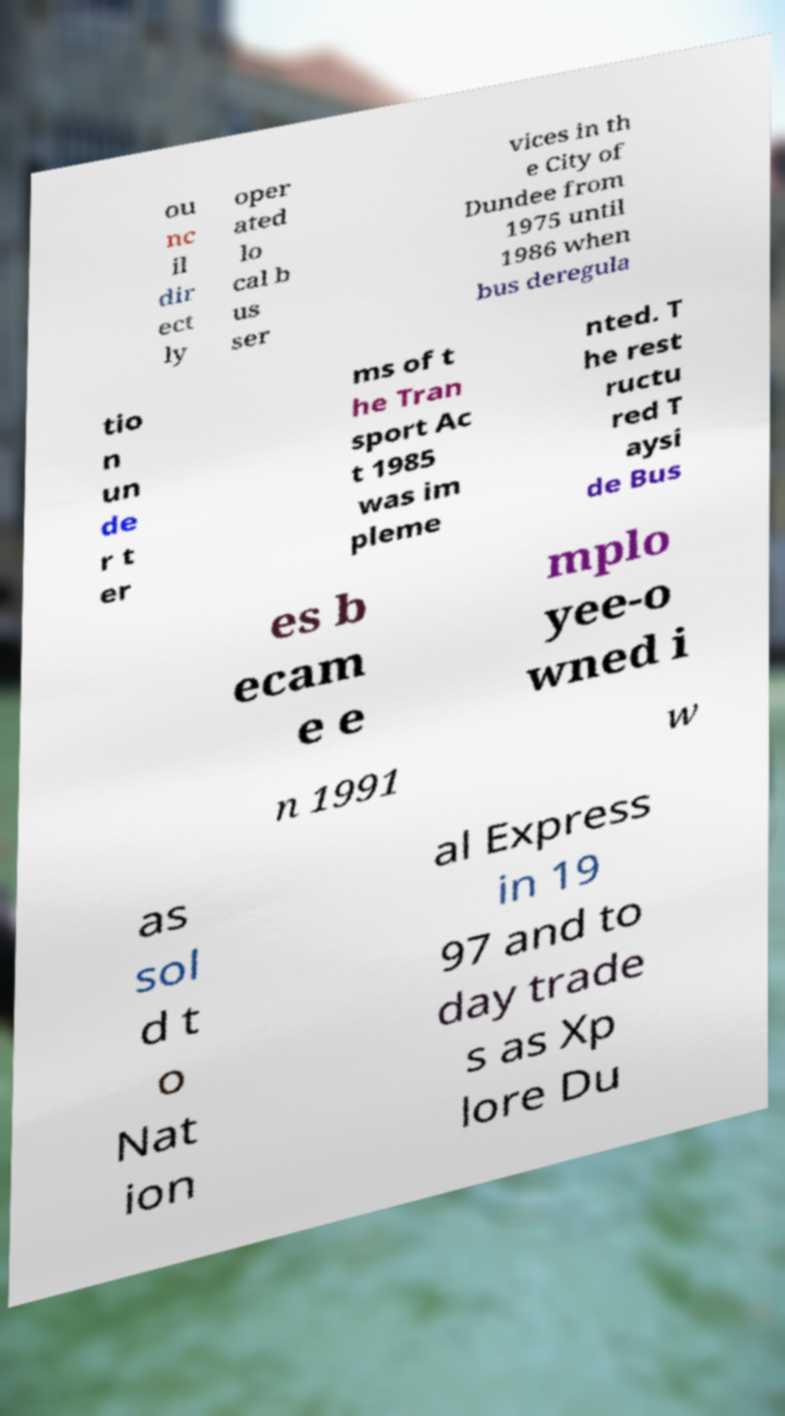Can you accurately transcribe the text from the provided image for me? ou nc il dir ect ly oper ated lo cal b us ser vices in th e City of Dundee from 1975 until 1986 when bus deregula tio n un de r t er ms of t he Tran sport Ac t 1985 was im pleme nted. T he rest ructu red T aysi de Bus es b ecam e e mplo yee-o wned i n 1991 w as sol d t o Nat ion al Express in 19 97 and to day trade s as Xp lore Du 